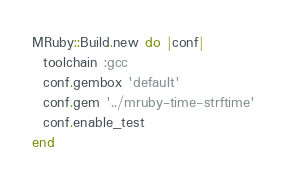Convert code to text. <code><loc_0><loc_0><loc_500><loc_500><_Ruby_>MRuby::Build.new do |conf|
  toolchain :gcc
  conf.gembox 'default'
  conf.gem '../mruby-time-strftime'
  conf.enable_test
end
</code> 